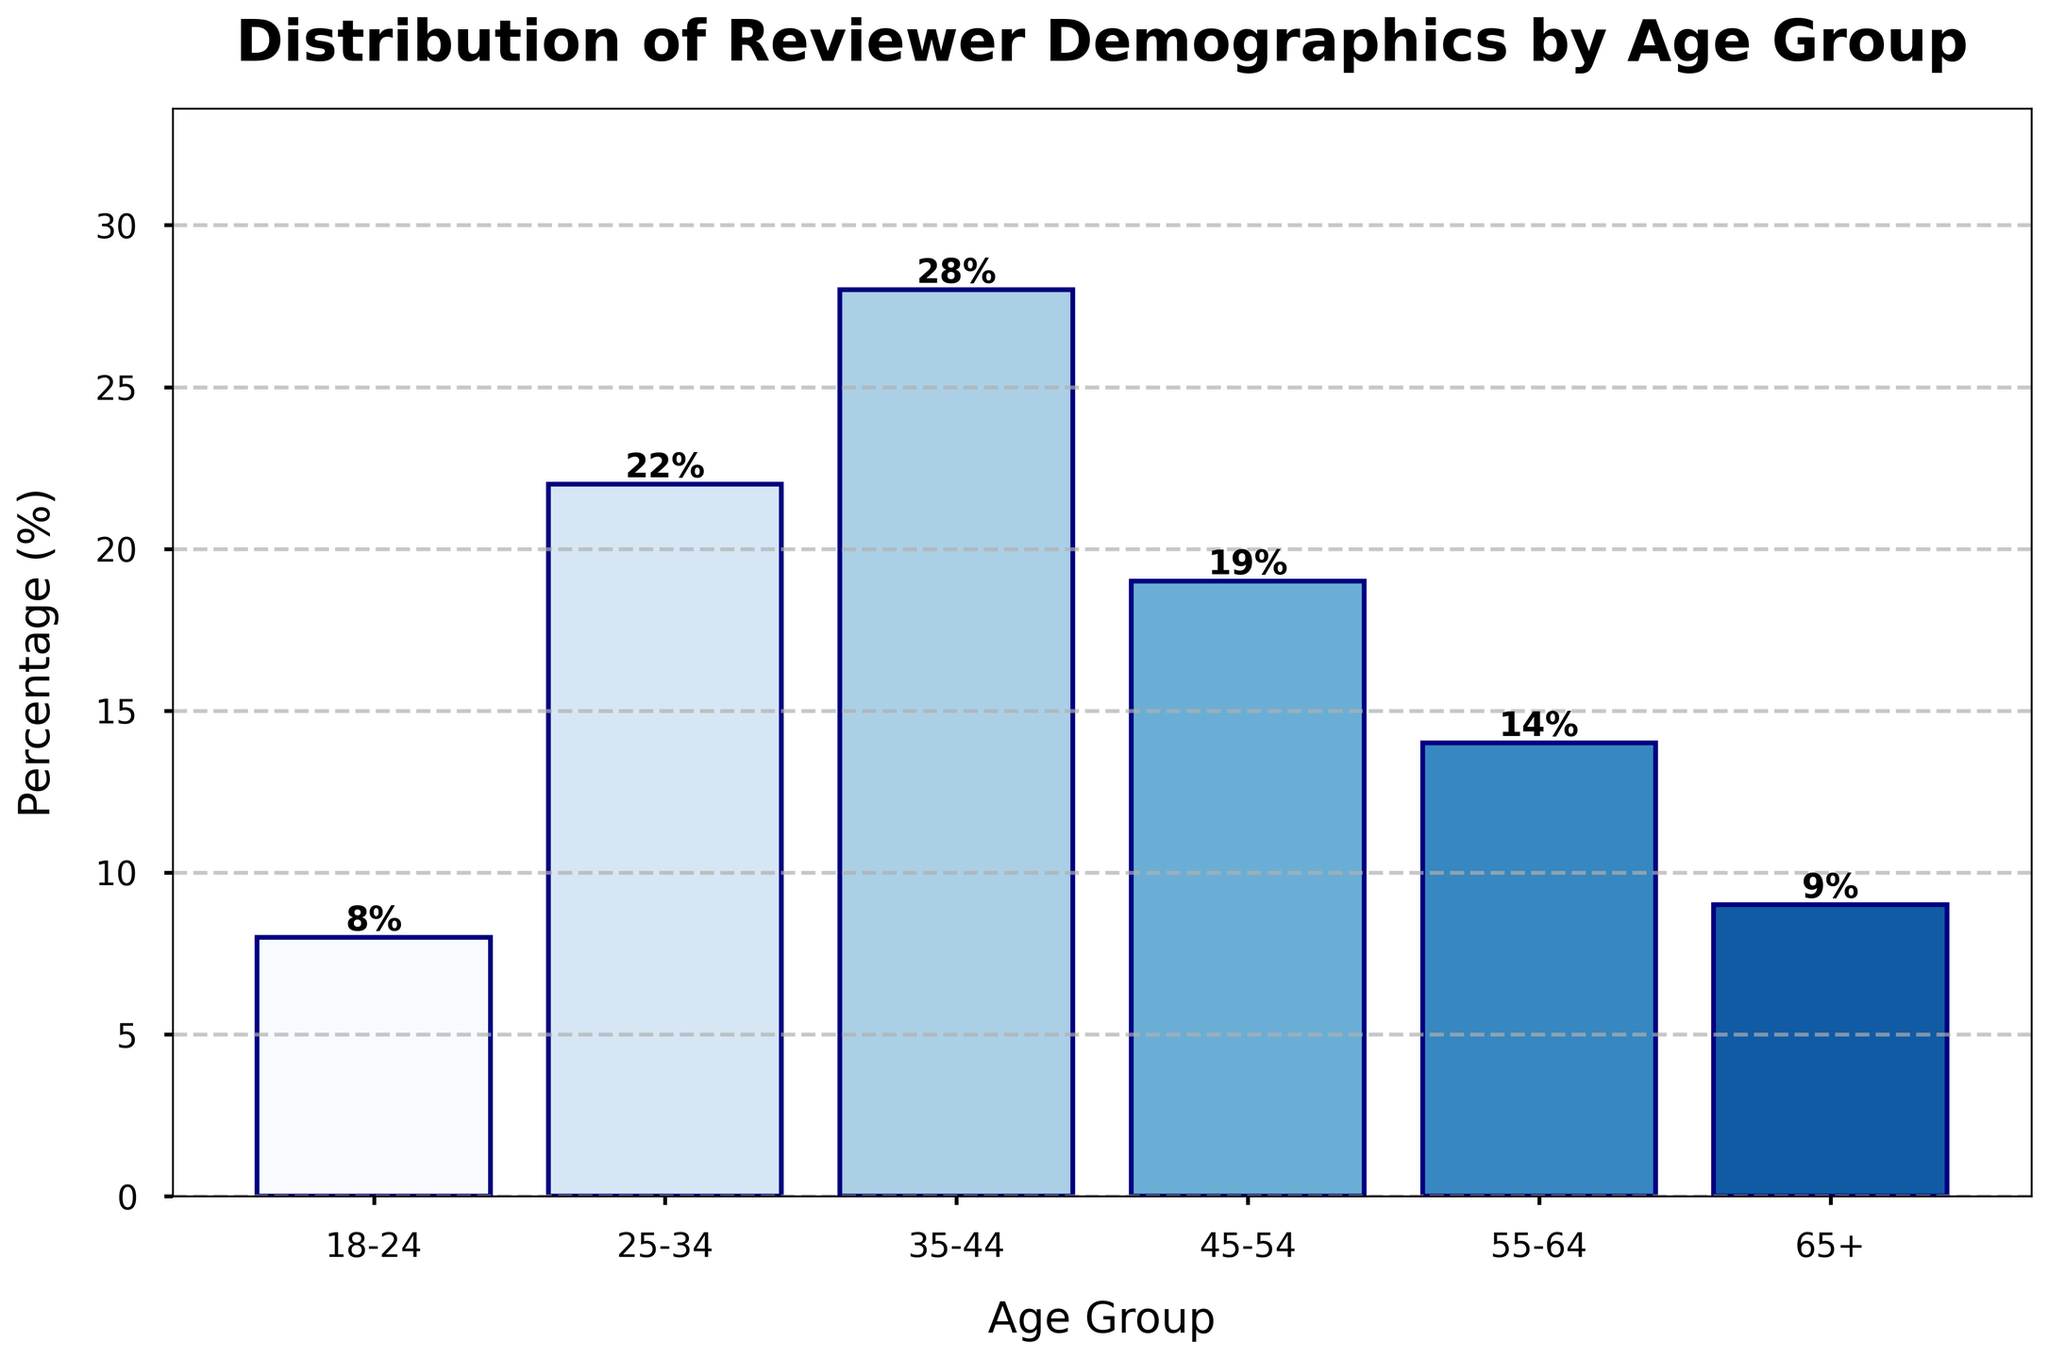What age group has the highest percentage of reviewers? By observing the height of the bars, the tallest bar represents the age group 35-44, indicating that it has the highest percentage.
Answer: 35-44 Which age group has the lowest percentage of reviewers? The shortest bar represents the age group 18-24, indicating that it has the lowest percentage.
Answer: 18-24 What is the combined percentage of reviewers aged 25-34 and 35-44? Add the percentages of the age group 25-34 (22%) and 35-44 (28%) to get the combined percentage: 22% + 28% = 50%.
Answer: 50% How does the percentage of reviewers aged 45-54 compare to those aged 55-64? The bar for the age group 45-54 is taller than the bar for the age group 55-64. The percentages are 19% and 14%, respectively, so 45-54 has a higher percentage.
Answer: 45-54 has a higher percentage What is the average percentage of the age groups 35-44, 45-54, and 55-64? The average can be found by adding the percentages and dividing by the number of groups: (28% + 19% + 14%) / 3 = 61% / 3 = 20.33%.
Answer: 20.33% Which two age groups have a similar percentage of reviewers, and what is that percentage? By comparing the heights of the bars, we see that the age groups 18-24 (8%) and 65+ (9%) have similar percentages.
Answer: 18-24 and 65+ have similar percentages What is the difference in percentage between the age groups 35-44 and 55-64? Subtract the percentage of 55-64 from 35-44: 28% - 14% = 14%.
Answer: 14% How many age groups have a percentage of reviewers above 20%? Count the bars that exceed the 20% mark. The age groups 25-34 and 35-44 both exceed this threshold.
Answer: 2 What percentage of reviewers fall into the age group 18-24 compared to the total percentage of other age groups combined? First find the total percentage of other age groups combined: 100% - 8% (18-24) = 92%.
Answer: 8% of 18-24 compared to 92% of others By how much does the percentage of reviewers aged 25-34 exceed the percentage of those aged 18-24? Subtract the percentage of 18-24 from 25-34: 22% - 8% = 14%.
Answer: 14% 